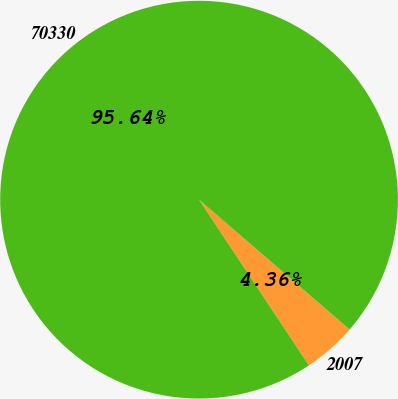Convert chart to OTSL. <chart><loc_0><loc_0><loc_500><loc_500><pie_chart><fcel>2007<fcel>70330<nl><fcel>4.36%<fcel>95.64%<nl></chart> 